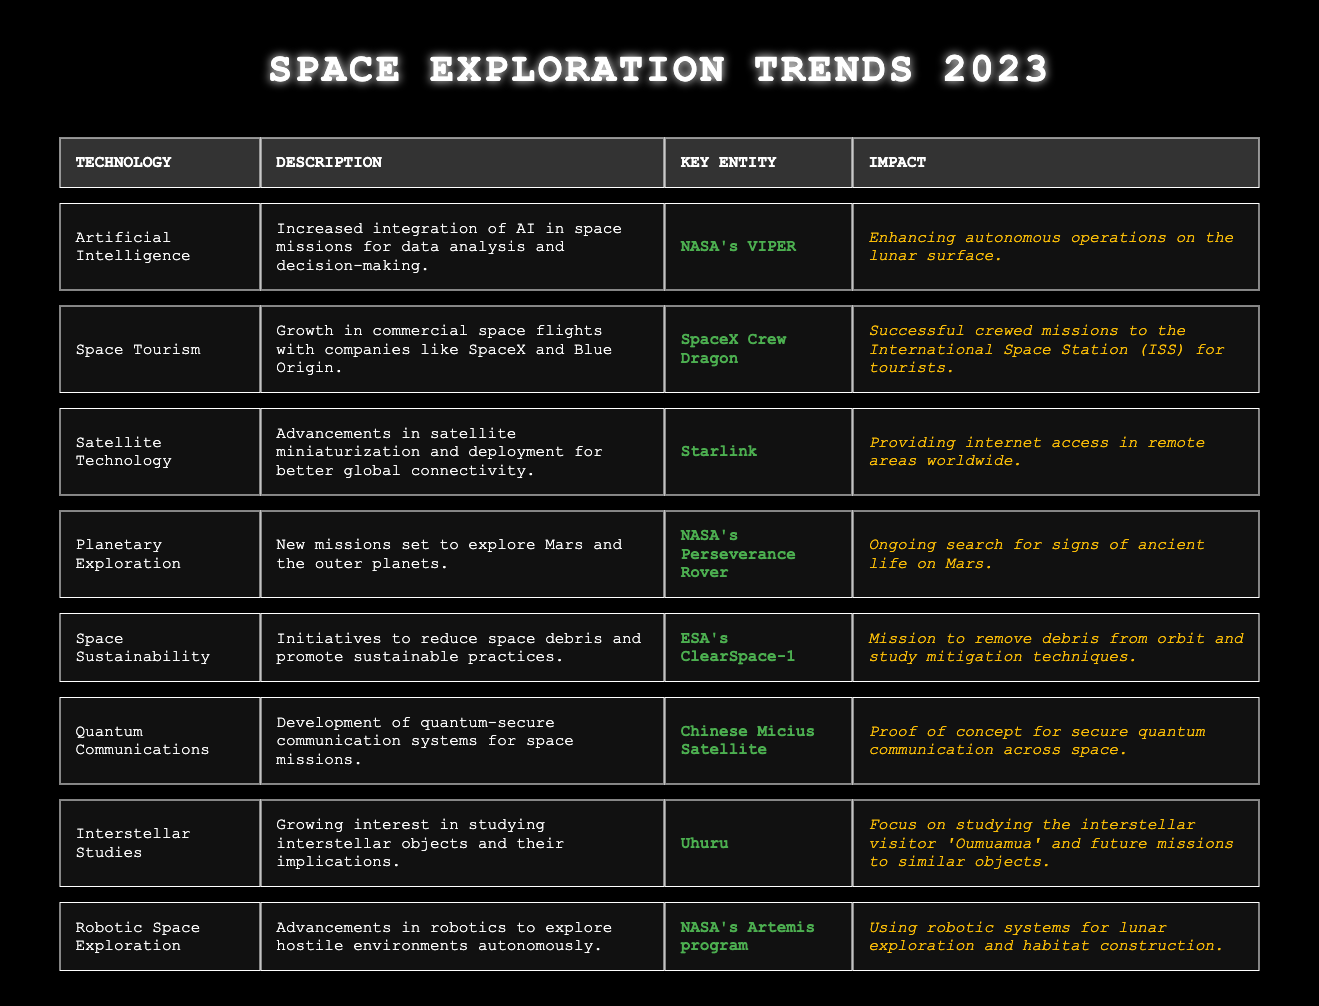What technology aims to enhance autonomous operations on the lunar surface? The table lists a specific technology, "Artificial Intelligence," and states its impact as "Enhancing autonomous operations on the lunar surface."
Answer: Artificial Intelligence Which key entity is associated with space tourism in 2023? The table mentions "SpaceX Crew Dragon" as the key entity related to the technology of Space Tourism.
Answer: SpaceX Crew Dragon What is the impact of Starlink technology? The table indicates that the impact of Starlink technology is "Providing internet access in remote areas worldwide."
Answer: Providing internet access in remote areas worldwide Is ESA's ClearSpace-1 focused on creating space debris? The description for ESA's ClearSpace-1 indicates it is focused on initiatives to reduce space debris, hence the statement is false.
Answer: False Which technology involves studying the interstellar visitor 'Oumuamua'? The table notes that the technology "Interstellar Studies" is focused on studying 'Oumuamua'.
Answer: Interstellar Studies What are the two technologies mentioned that are related to planetary exploration? The technologies related to planetary exploration are "Planetary Exploration" and "Robotic Space Exploration", as they both mention actions associated with exploring planets.
Answer: Planetary Exploration, Robotic Space Exploration How many technologies focus on sustainability in space? The table shows only one technology, "Space Sustainability," that has a specific sustainability initiative mentioned, which is ESA's ClearSpace-1 as part of reducing debris.
Answer: One What is the impact of NASA's Perseverance Rover? According to the table, the impact of NASA's Perseverance Rover is to conduct "Ongoing search for signs of ancient life on Mars."
Answer: Ongoing search for signs of ancient life on Mars Which technology has the key entity Chinese Micius Satellite? The technology linked with the Chinese Micius Satellite is "Quantum Communications" according to the data provided in the table.
Answer: Quantum Communications Compare the number of technologies related to communication and exploration in the table. There are two communication technologies (Quantum Communications) and three exploration technologies (Planetary Exploration, Robotic Space Exploration, and Interstellar Studies), indicating that exploration technologies outnumber communication technologies.
Answer: Exploration technologies outnumber communication technologies 